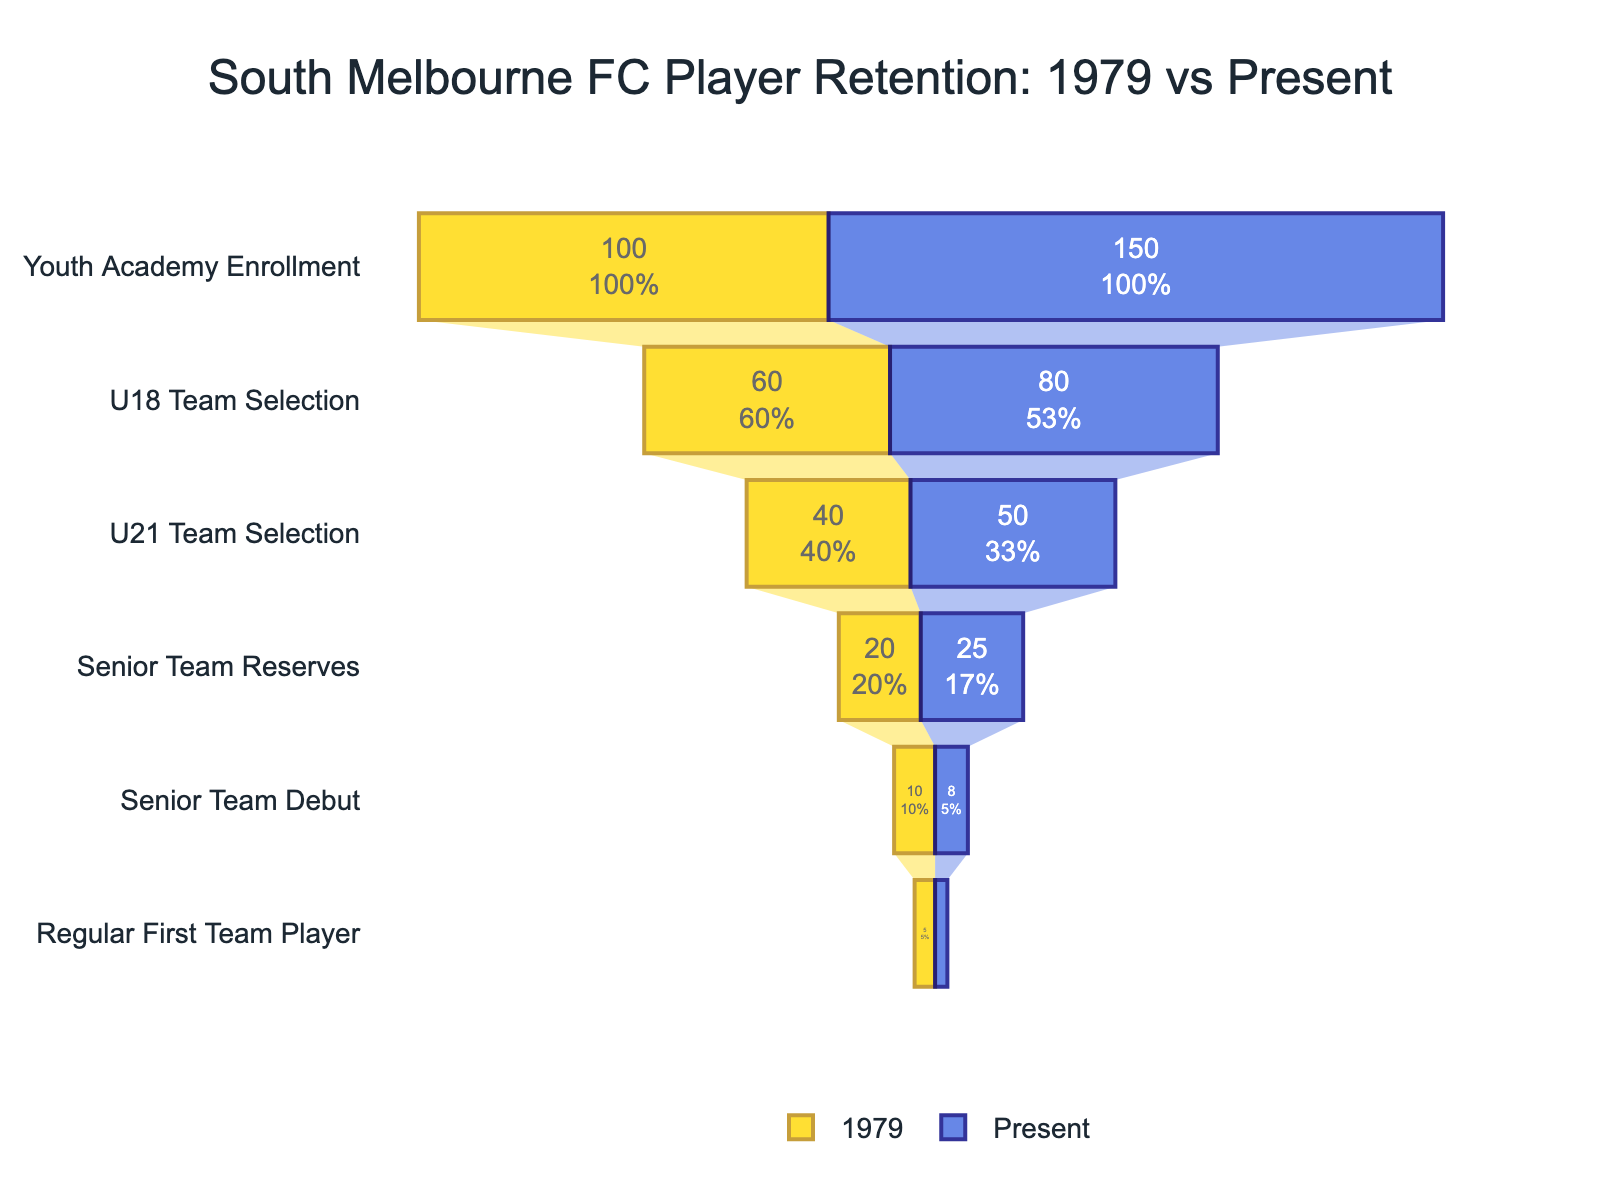What's the title of the figure? The title is usually found at the top of the figure and is often larger in font to stand out. In this case, the title is "South Melbourne FC Player Retention: 1979 vs Present."
Answer: South Melbourne FC Player Retention: 1979 vs Present How many players from the youth academy made their debut for the senior team in 1979? To find this, we track the funnel chart for the year 1979 from the "Youth Academy Enrollment" stage to the "Senior Team Debut" stage. According to the data, 100 players were enrolled, and 10 made their debut.
Answer: 10 What is the difference in the number of players moving from the U18 Team to the U21 Team between 1979 and the present? For 1979, 60 players were selected for the U18 Team and 40 for the U21 Team, a difference of 20. For the present, 80 players were selected for the U18 Team and 50 for the U21 Team, a difference of 30. The difference between these differences is 30 - 20.
Answer: 10 What's the percentage drop in players from the U21 Team to the Senior Team Reserves in 1979? In 1979, the funnel chart shows 40 players in the U21 Team and 20 in the Senior Team Reserves. The percentage drop is calculated as ((40 - 20) / 40) * 100.
Answer: 50% How many stages are there in the funnel chart? The stages are listed on the y-axis of the funnel chart. Counting from "Youth Academy Enrollment" to "Regular First Team Player," there are six stages.
Answer: 6 Between 1979 and the present, in which year did more players move from the youth academy to the U18 team? For 1979, 60 players moved from the youth academy to the U18 team. For the present, 80 players moved. Therefore, more players moved in the present year.
Answer: Present By what factor did the number of Regular First Team players decrease from 1979 to present? In 1979, there were 5 Regular First Team players, and in the present, there are 3. The decrease factor is calculated as 5 / 3.
Answer: ~1.67 What is the final retention rate from the youth academy to Regular First Team players for the present? For the present, 150 players were initially enrolled in the youth academy, and 3 became Regular First Team players. The retention rate is (3 / 150) * 100.
Answer: 2% Which stage has the smallest percentage drop from the previous stage for the present year? To find the smallest percentage drop for the present year, calculate the drops between each stage and compare them. The stages have the following drops: 
   - "Youth Academy Enrollment" to "U18 Team Selection": ((150 - 80) / 150) * 100 = 46.67%
   - "U18 Team Selection" to "U21 Team Selection": ((80 - 50) / 80) * 100 = 37.5%
   - "U21 Team Selection" to "Senior Team Reserves": ((50 - 25) / 50) * 100 = 50%
   - "Senior Team Reserves" to "Senior Team Debut": ((25 - 8) / 25) * 100 = 68%
   - "Senior Team Debut" to "Regular First Team Player": ((8 - 3) / 8) * 100 = 62.5%
The smallest drop is between "U18 Team Selection" and "U21 Team Selection."
Answer: "U18 Team Selection" to "U21 Team Selection" How many more players were enrolled in the youth academy in the present compared to 1979? The number of players enrolled in the youth academy for 1979 was 100, and 150 for the present. The difference is 150 - 100.
Answer: 50 